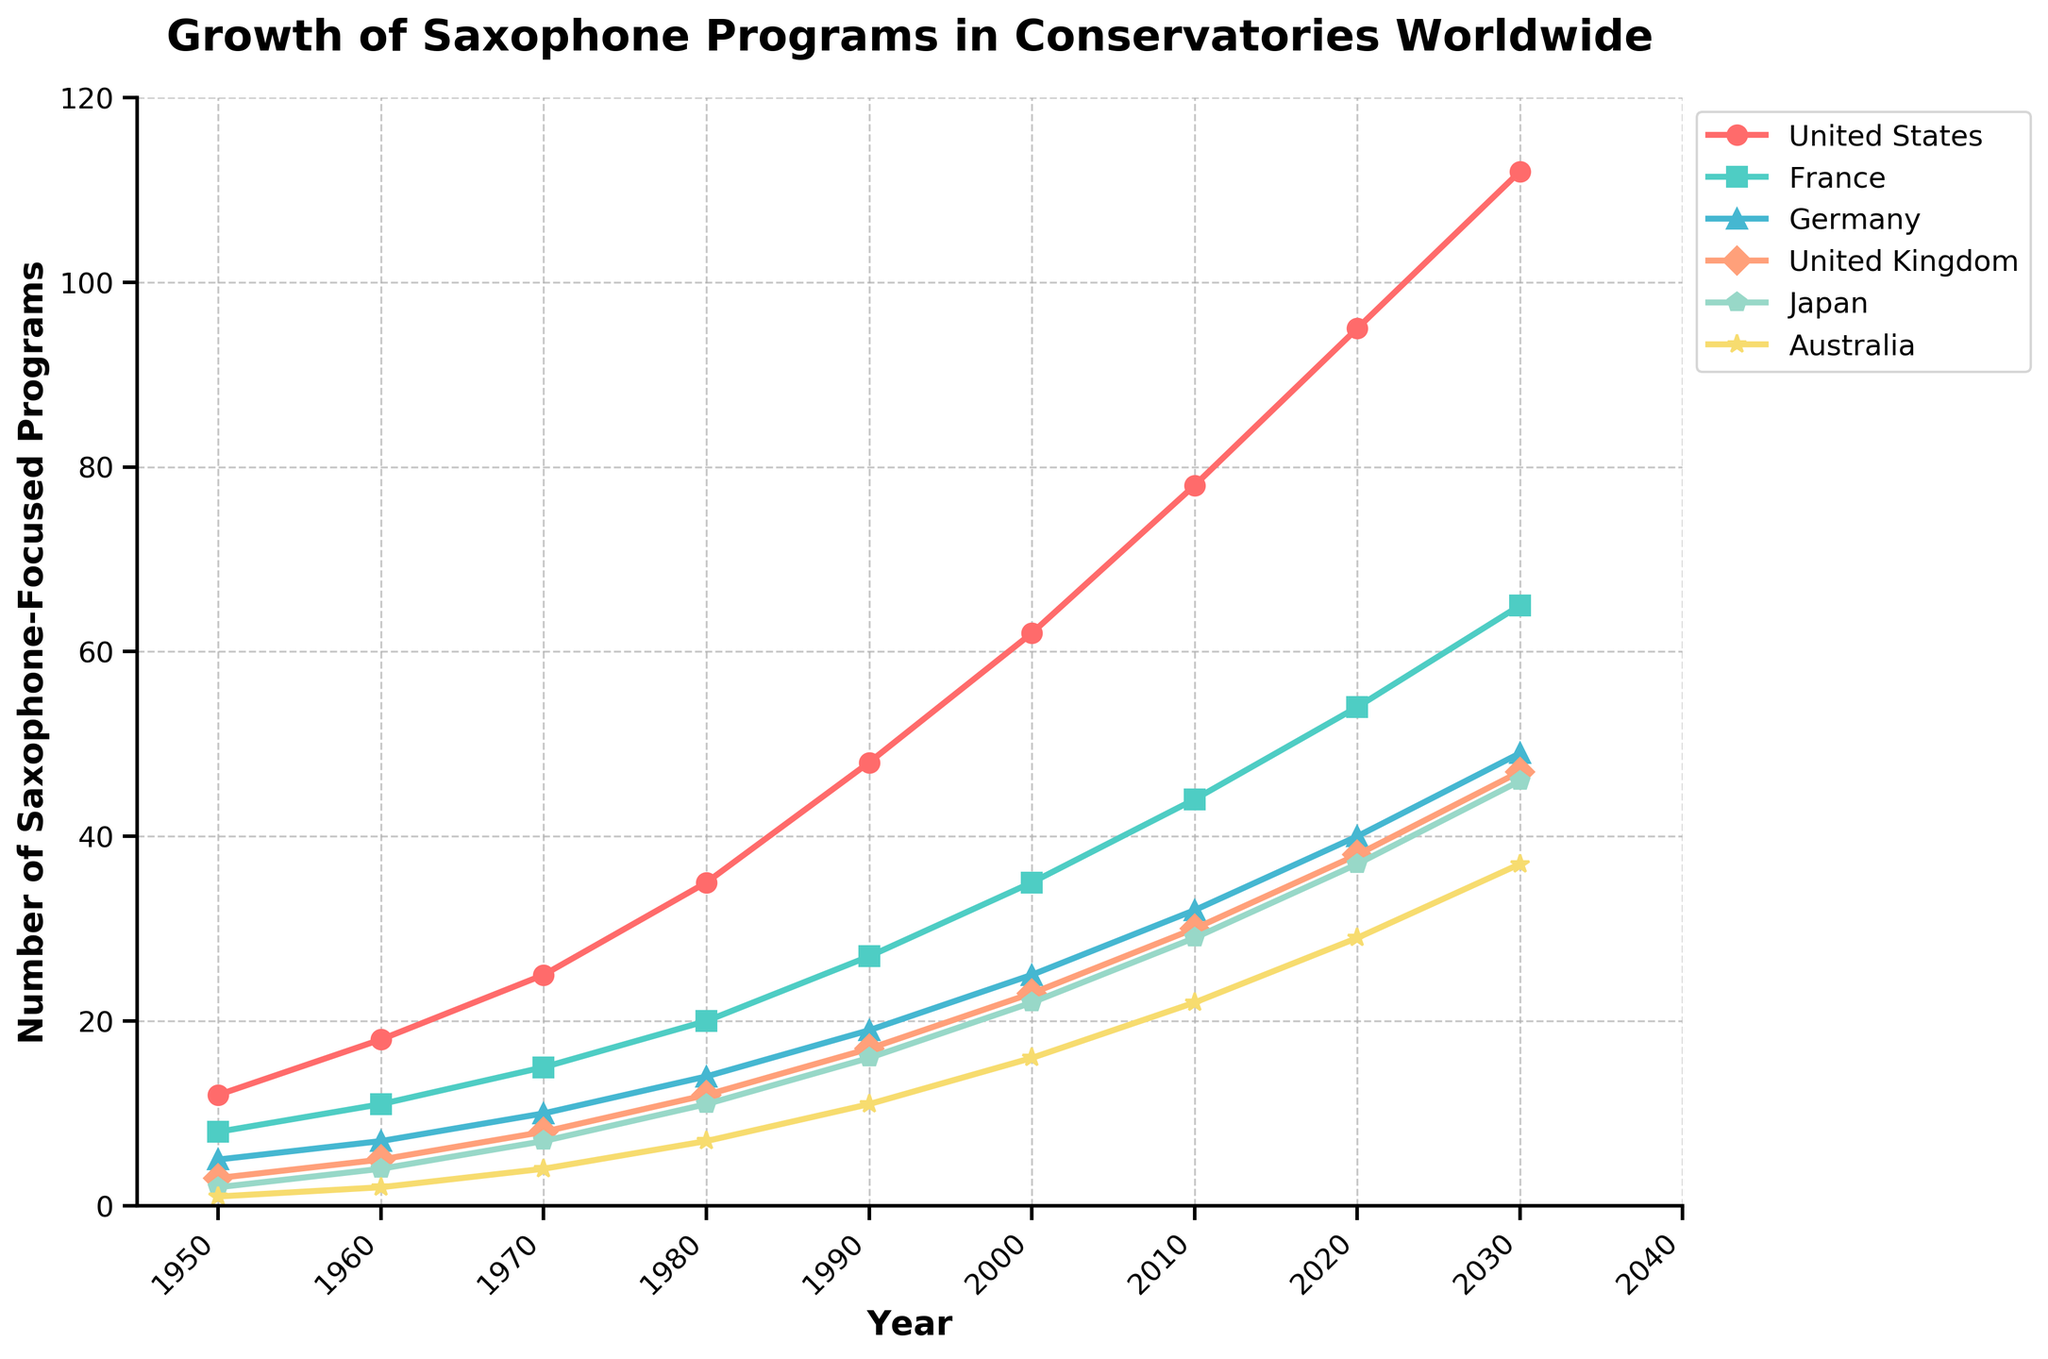Which country had the highest number of saxophone-focused programs in 2020? The red line represents the United States, which shows the highest value in 2020 at 95.
Answer: United States Which two countries had the smallest increase in the number of saxophone-focused programs from 1950 to 2030? Subtract the initial values from the final values for each country. Australia increased by 36 (37-1) and Japan increased by 44 (46-2), which are the smallest increases.
Answer: Australia, Japan How many saxophone-focused music programs were offered in total by the United States and Germany in 1990? Add the values for the United States and Germany in 1990 (48 and 19, respectively). 48 + 19 = 67.
Answer: 67 In which decade did France see the steepest increase in saxophone-focused programs? Calculate the differences for each decade: 1950-1960 (+3), 1960-1970 (+4), 1970-1980 (+5), 1980-1990 (+7), 1990-2000 (+8), 2000-2010 (+9), 2010-2020 (+10). The steepest increase occurred between 2000 and 2010.
Answer: 2000-2010 Between which consecutive decades did Japan's number of saxophone-focused programs show the greatest increase? Calculate the differences for each decade: 1950-1960 (+2), 1960-1970 (+3), 1970-1980 (+4), 1980-1990 (+5), 1990-2000 (+6), 2000-2010 (+7), 2010-2020 (+8). The greatest increase is from 2010 to 2020.
Answer: 2010-2020 Which country had the smallest number of saxophone-focused programs in 1950, and how many programs did it have? Look for the smallest value in 1950. Australia had the smallest number with 1 program.
Answer: Australia, 1 What is the average number of saxophone-focused music programs offered by the United Kingdom from 1950 to 2030? Average = (Sum of all values) / (Number of values). (3 + 5 + 8 + 12 + 17 + 23 + 30 + 38 + 47) / 9 = 20.33.
Answer: 20.33 How does the trend of saxophone-focused programs in France compare to that in the United States? The US shows a consistently higher and steeper rise than France. Up to 2030, the US increased from 12 to 112 programs, while France increased from 8 to 65.
Answer: The US trend is higher and steeper Which country had the second-highest number of saxophone-focused programs in 1970? In 1970, the values were: United States (25), France (15), Germany (10), United Kingdom (8), Japan (7), Australia (4). France had the second-highest number with 15 programs.
Answer: France What's the total number of saxophone-focused programs offered by these countries in 2000? Sum all values for 2000: 62 + 35 + 25 + 23 + 22 + 16 = 183.
Answer: 183 